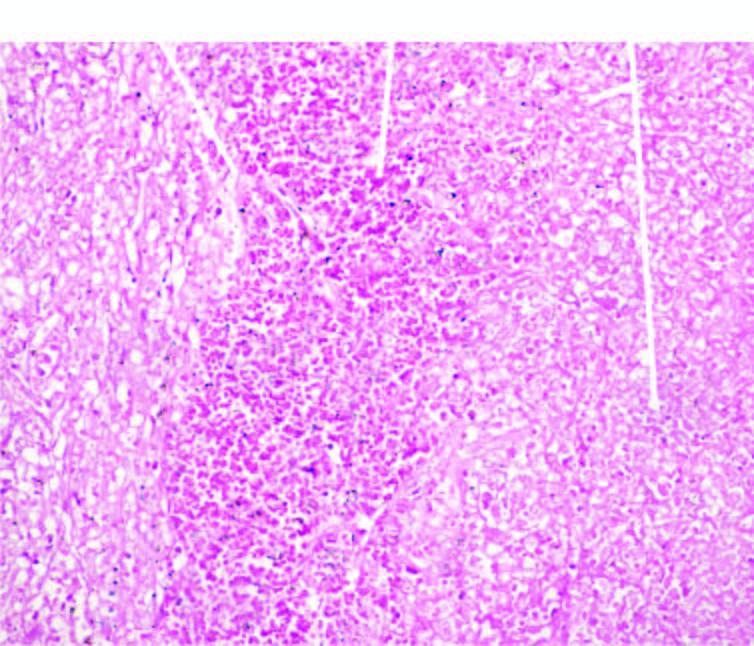does the affected area show outlines of cells only due to coagulative necrosis while the margin of infracted area shows haemorrhage?
Answer the question using a single word or phrase. Yes 